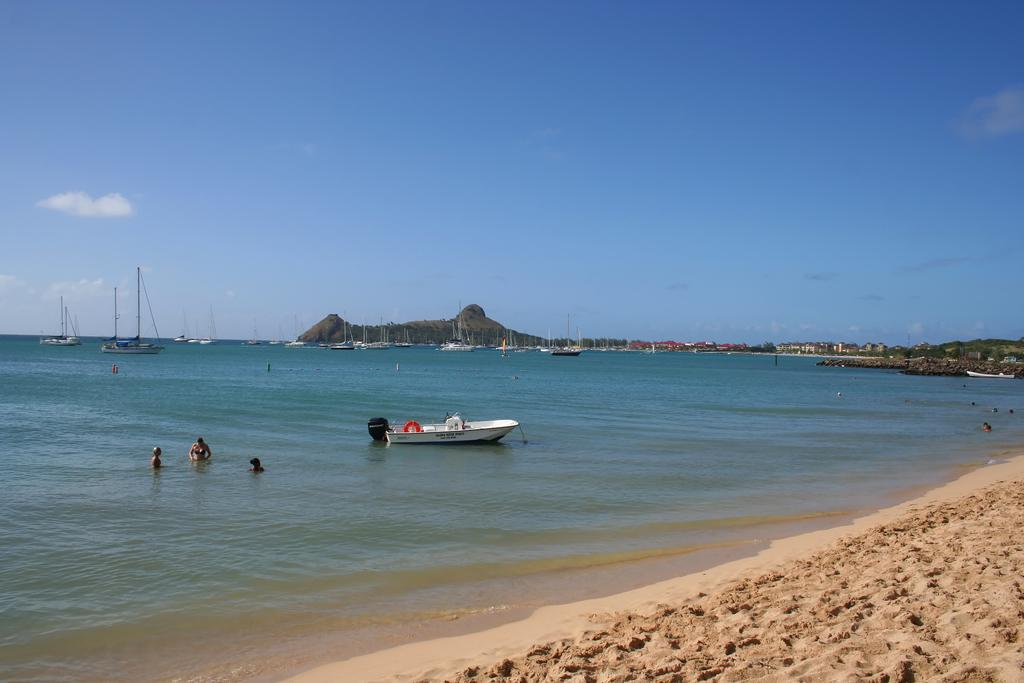What is the main subject in the foreground of the image? There is a boat in the foreground of the image. What is the boat's location in relation to the water? The boat is on the water. What can be seen in the water besides the boat? There are persons in the water. What other boats can be seen in the image? There are boats in the background of the image. What type of landscape feature is visible in the background? There is a cliff in the background of the image. What is visible in the sky? The sky is visible in the background of the image, and there are clouds in the sky. How many accounts does the visitor have in the image? There is no mention of an account or a visitor in the image. What type of pigs can be seen swimming in the water? There are no pigs present in the image; only persons are seen in the water. 